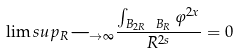Convert formula to latex. <formula><loc_0><loc_0><loc_500><loc_500>\lim s u p _ { R \longrightarrow \infty } \frac { \int _ { B _ { 2 R } \ B _ { R } } \varphi ^ { 2 x } } { R ^ { 2 s } } = 0</formula> 